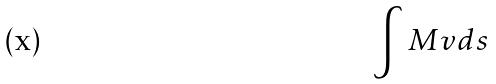Convert formula to latex. <formula><loc_0><loc_0><loc_500><loc_500>\int M v d s</formula> 